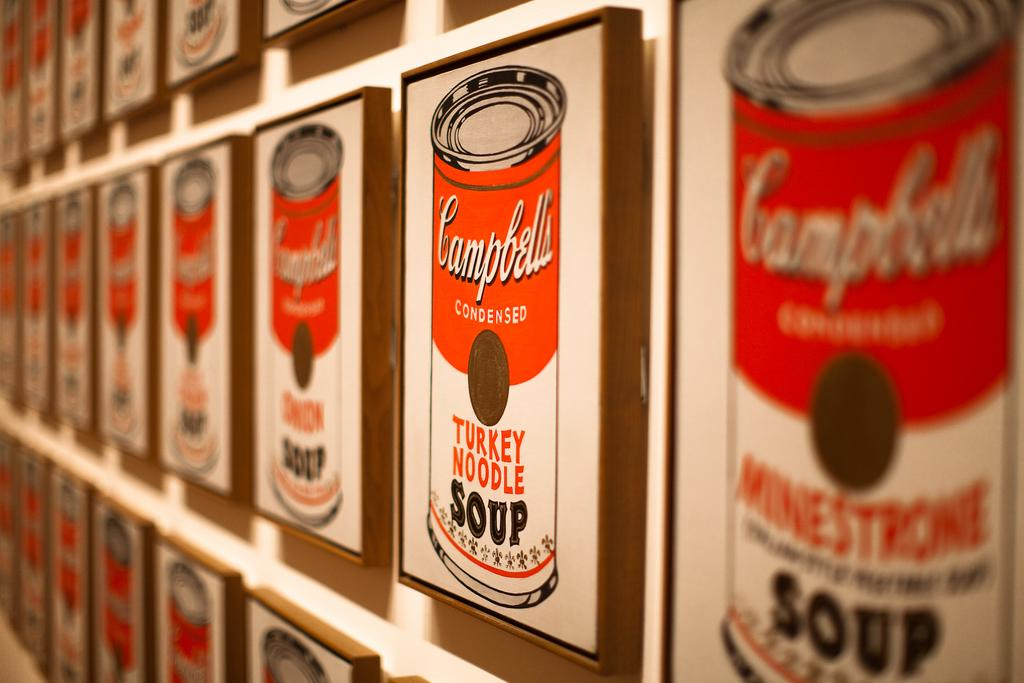<image>
Describe the image concisely. A wall of Campbell's turkey noodle soup patterns. 